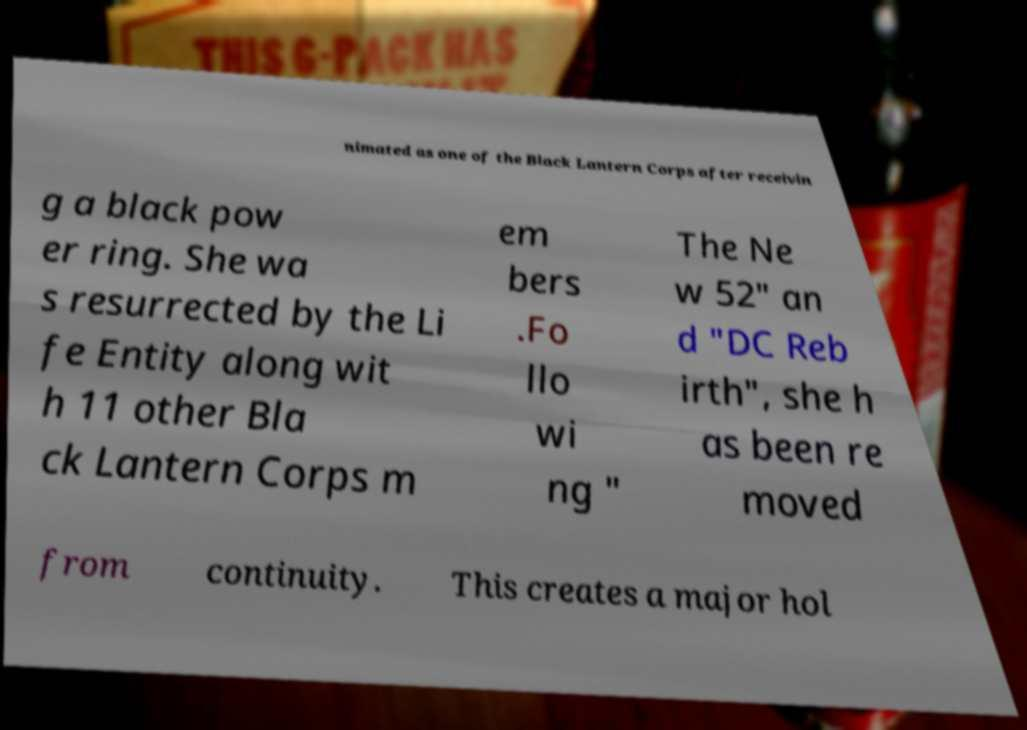There's text embedded in this image that I need extracted. Can you transcribe it verbatim? nimated as one of the Black Lantern Corps after receivin g a black pow er ring. She wa s resurrected by the Li fe Entity along wit h 11 other Bla ck Lantern Corps m em bers .Fo llo wi ng " The Ne w 52" an d "DC Reb irth", she h as been re moved from continuity. This creates a major hol 